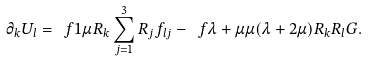Convert formula to latex. <formula><loc_0><loc_0><loc_500><loc_500>\partial _ { k } U _ { l } = \ f { 1 } { \mu } R _ { k } \sum ^ { 3 } _ { j = 1 } R _ { j } f _ { l j } - \ f { \lambda + \mu } { \mu ( \lambda + 2 \mu ) } R _ { k } R _ { l } G .</formula> 